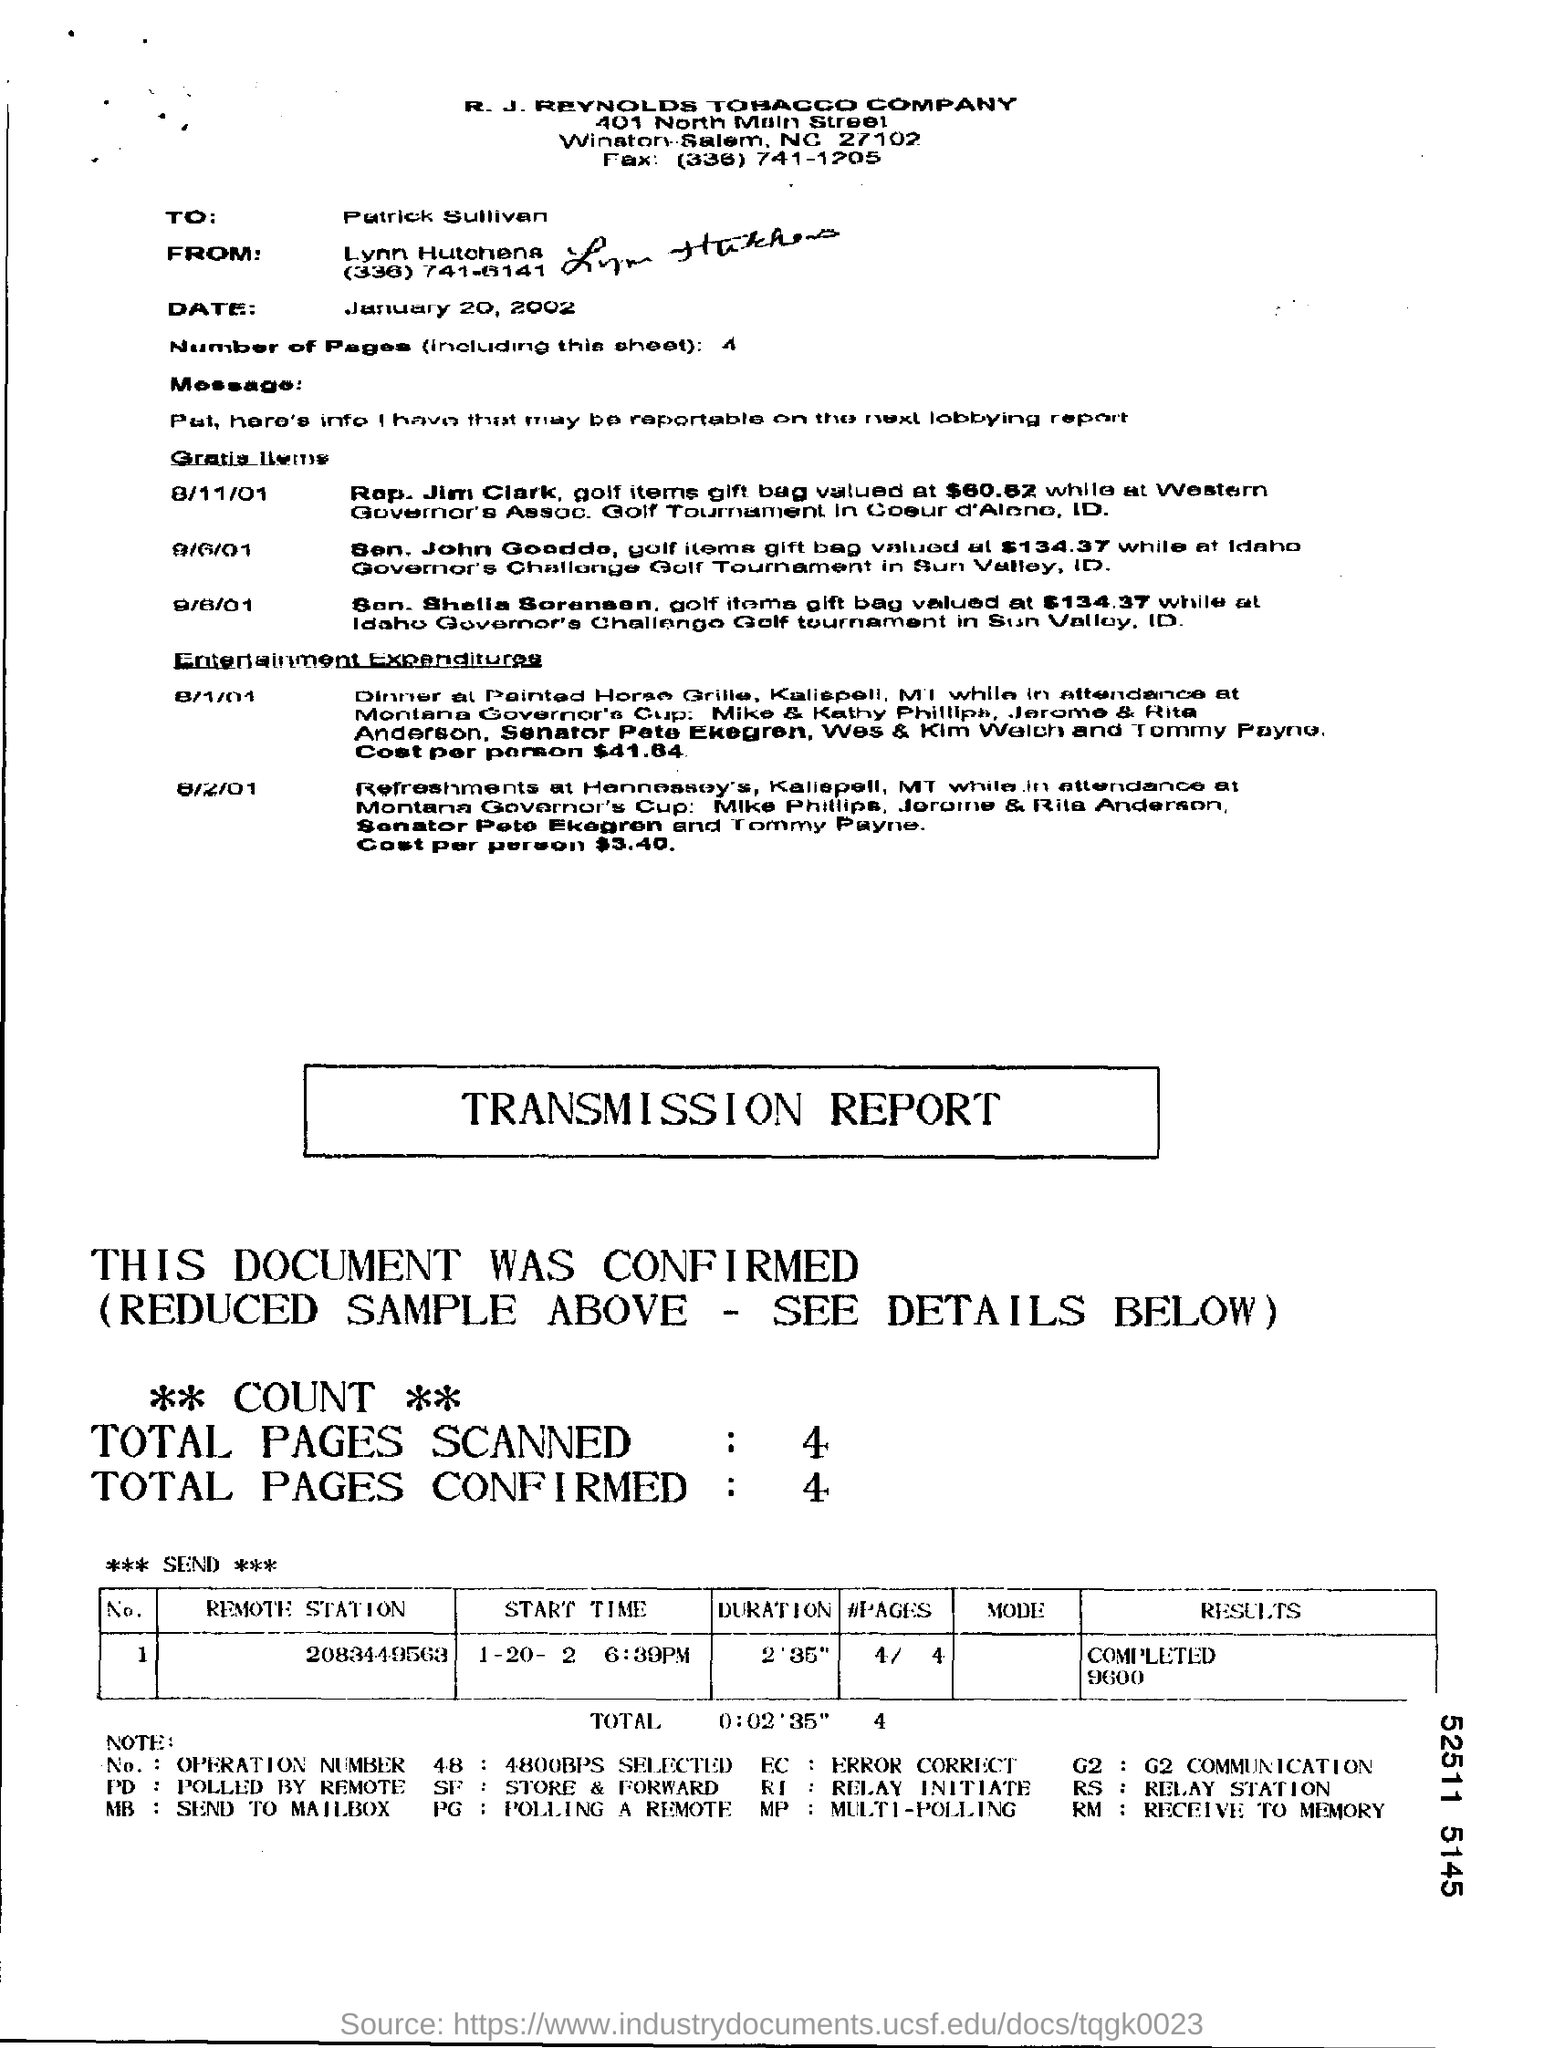How many number of pages (including this sheet) are there ?
Keep it short and to the point. 4. What is the number of pages in the fax including cover sheet?
Provide a short and direct response. 4. How many total pages are scanned ?
Make the answer very short. 4. In which state is r.j reynolds tobacco company at ?
Keep it short and to the point. NC. To whom is this message written to ?
Your response must be concise. Patrick Sullivan. 